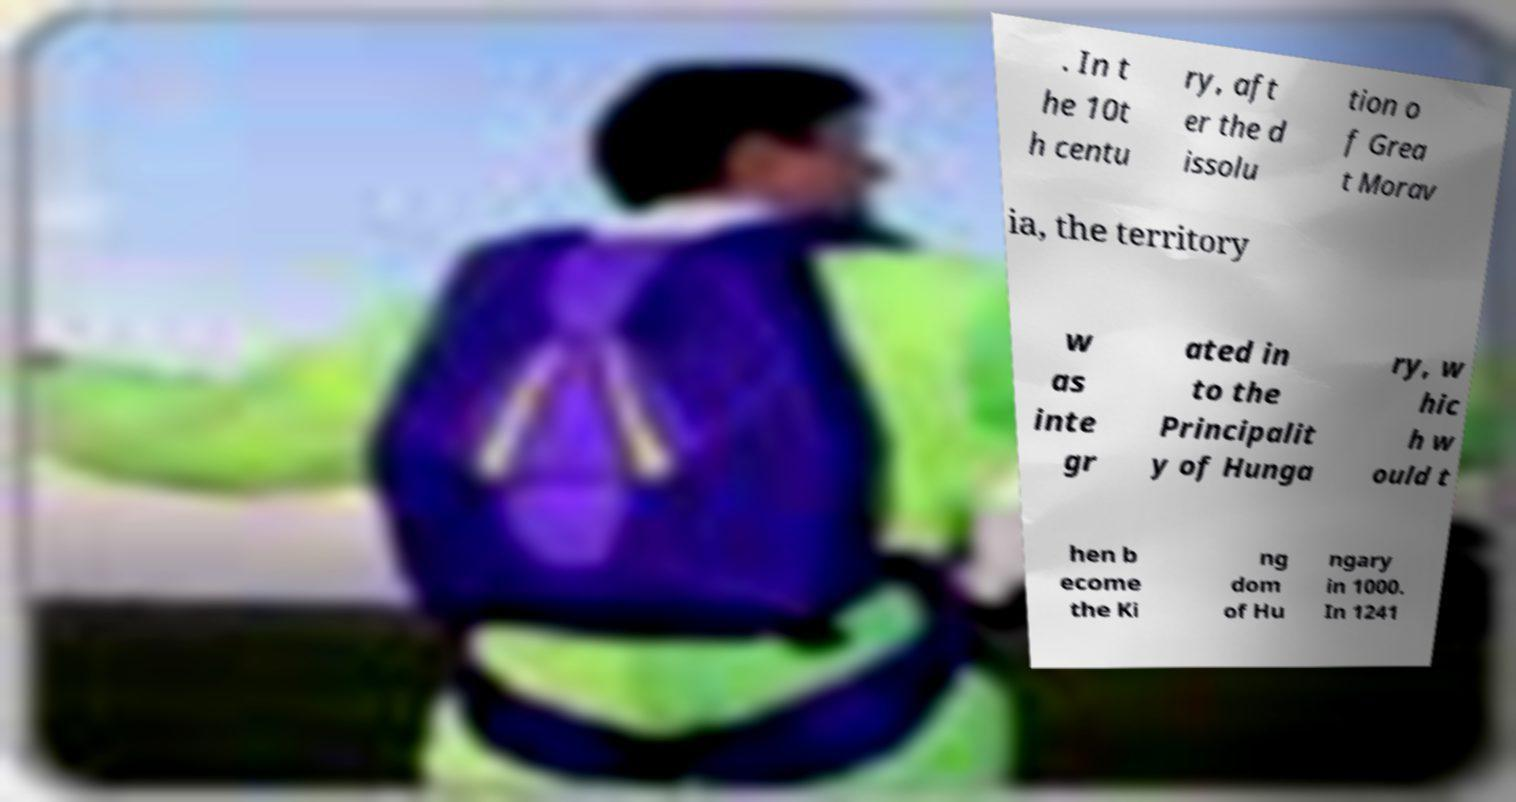What messages or text are displayed in this image? I need them in a readable, typed format. . In t he 10t h centu ry, aft er the d issolu tion o f Grea t Morav ia, the territory w as inte gr ated in to the Principalit y of Hunga ry, w hic h w ould t hen b ecome the Ki ng dom of Hu ngary in 1000. In 1241 